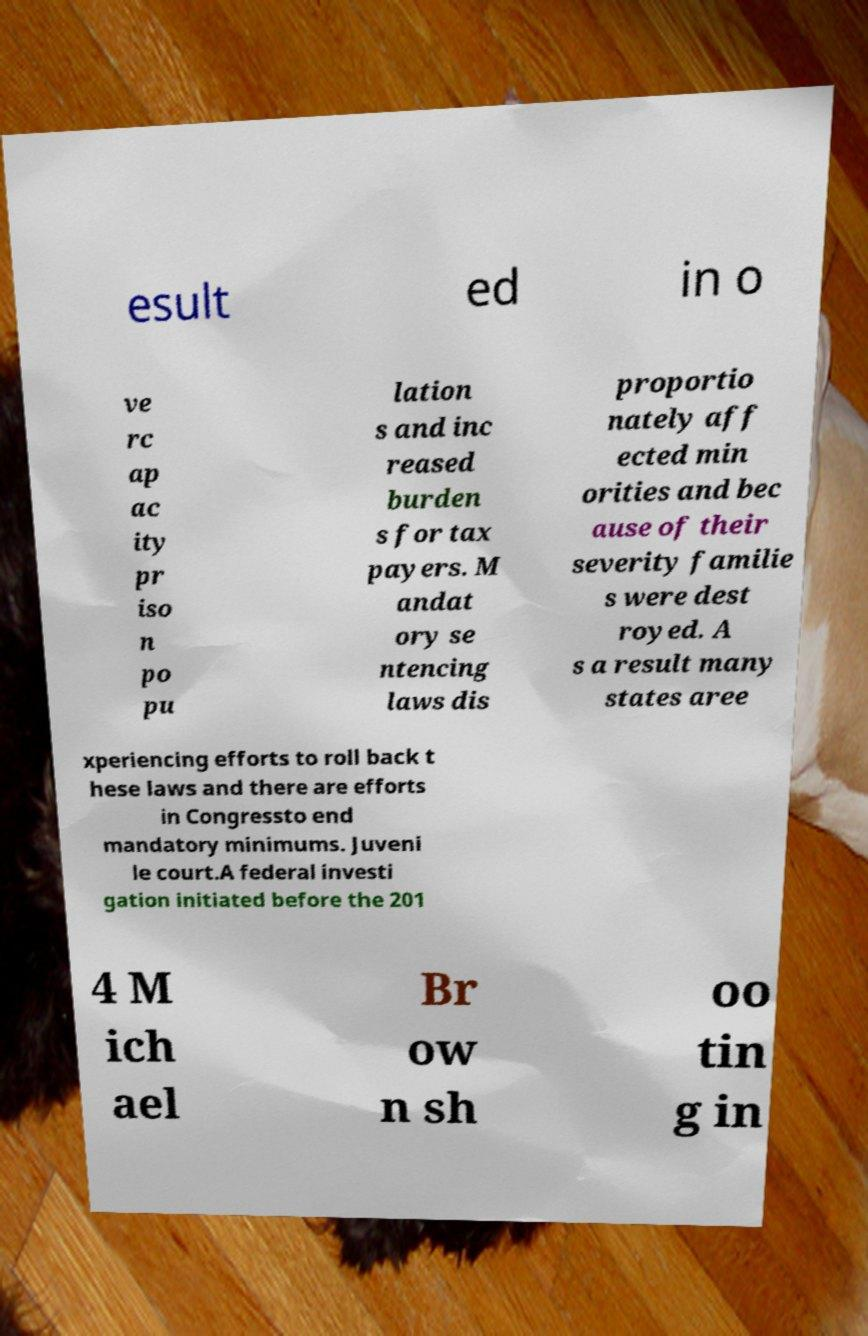Could you extract and type out the text from this image? esult ed in o ve rc ap ac ity pr iso n po pu lation s and inc reased burden s for tax payers. M andat ory se ntencing laws dis proportio nately aff ected min orities and bec ause of their severity familie s were dest royed. A s a result many states aree xperiencing efforts to roll back t hese laws and there are efforts in Congressto end mandatory minimums. Juveni le court.A federal investi gation initiated before the 201 4 M ich ael Br ow n sh oo tin g in 